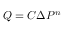Convert formula to latex. <formula><loc_0><loc_0><loc_500><loc_500>Q = C { \Delta } P ^ { n } \,</formula> 